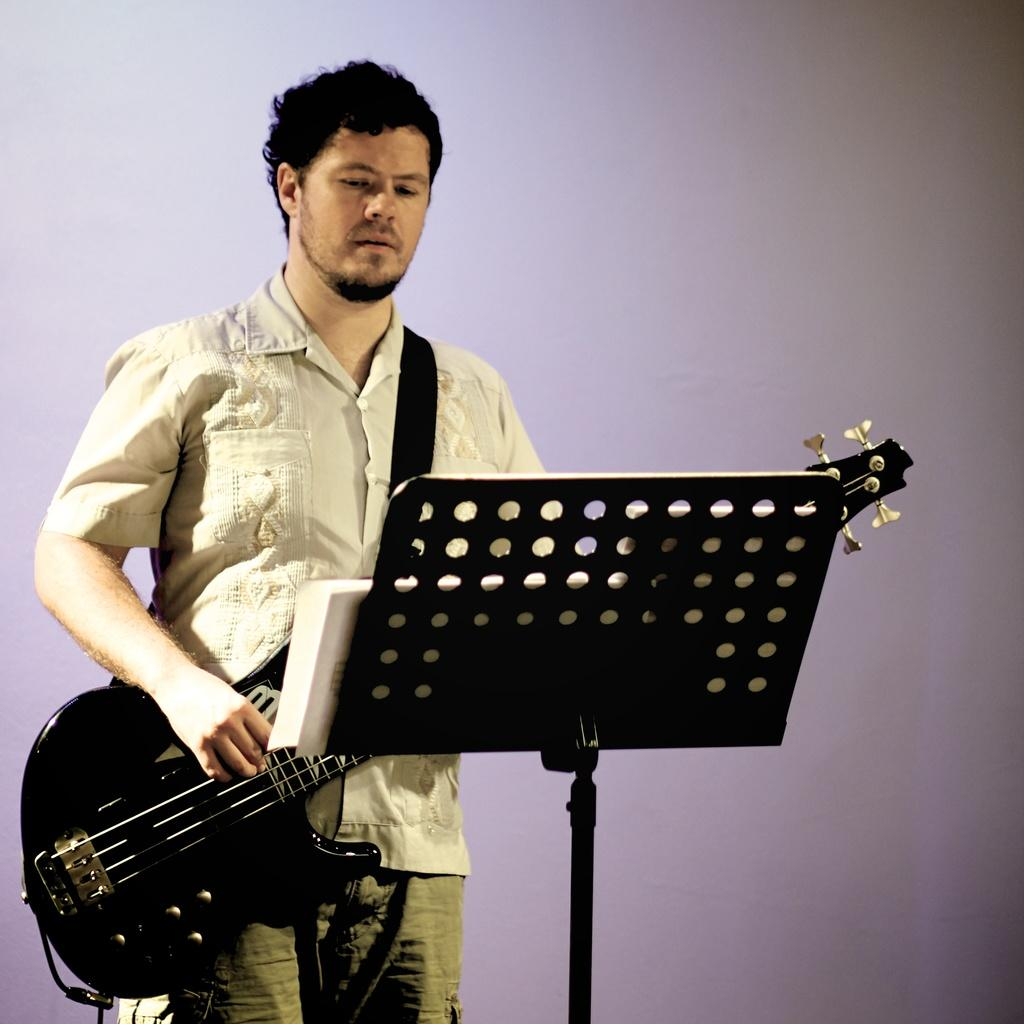Who is present in the image? There is a man in the image. What is the man doing in the image? The man is standing in the image. What object is the man holding in the image? The man is holding a guitar in the image. What is in front of the man in the image? There is a stand in front of the man in the image. How many tickets does the man have in his hand in the image? There are no tickets visible in the man's hand in the image. Is the man wearing a mask in the image? There is no indication of a mask being worn by the man in the image. 